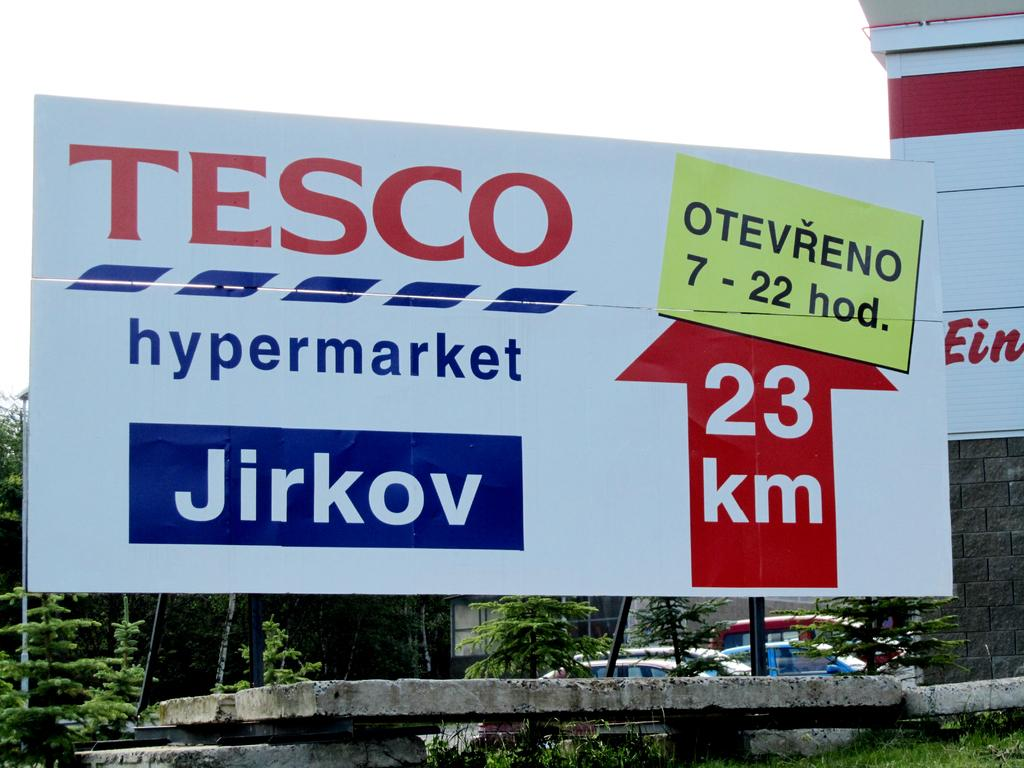<image>
Create a compact narrative representing the image presented. An arrow on a billboard shows the distance to Tesco as 23 kilometers. 